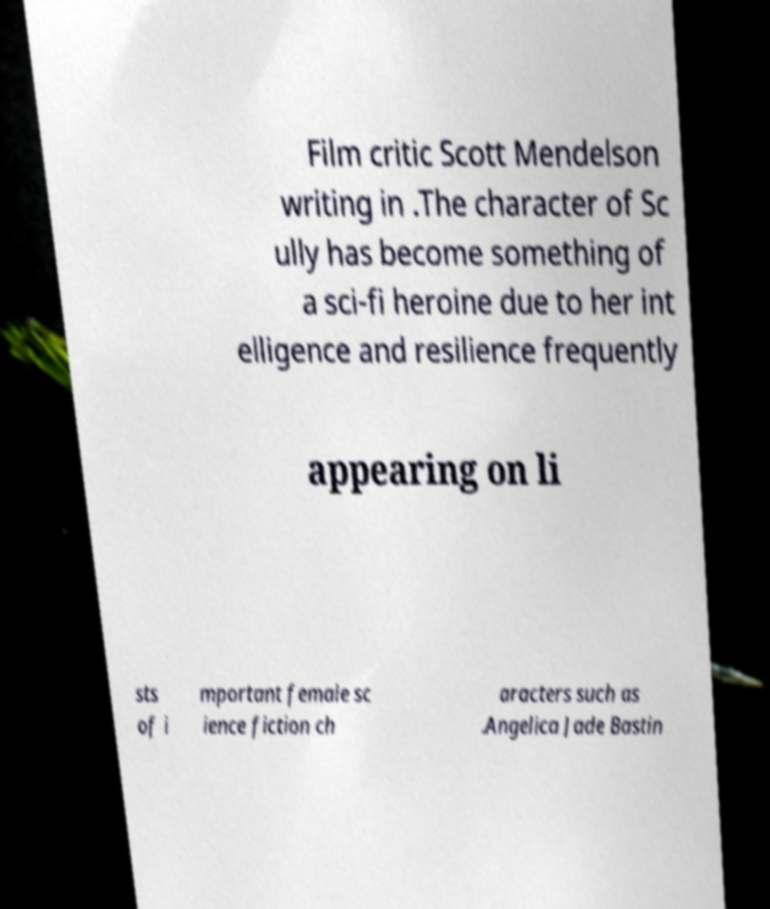Can you accurately transcribe the text from the provided image for me? Film critic Scott Mendelson writing in .The character of Sc ully has become something of a sci-fi heroine due to her int elligence and resilience frequently appearing on li sts of i mportant female sc ience fiction ch aracters such as .Angelica Jade Bastin 